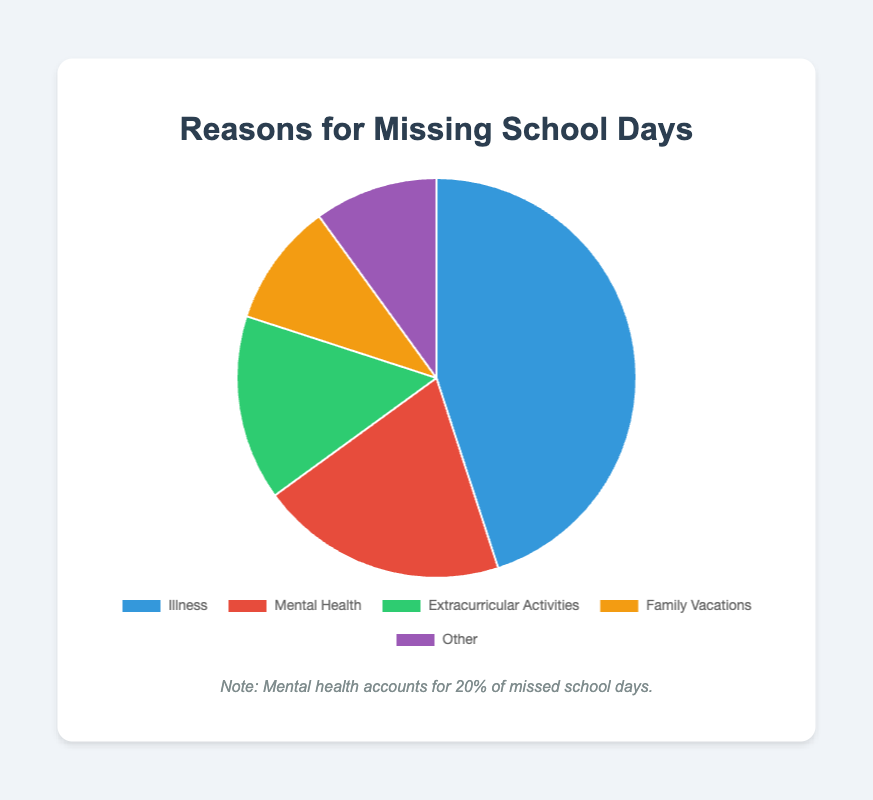What percentage of missed school days is due to illness? Illness is shown in the chart with a percentage value of 45%. Simply refer to the label for "Illness" to get the answer.
Answer: 45% What is the difference between the percentages of missed school days due to illness and mental health? The percentage for illness is 45%, and for mental health, it is 20%. Calculating the difference: 45% - 20% = 25%
Answer: 25% What percentage of missed school days is accounted for by extracurricular activities and family vacations combined? The percentages for extracurricular activities and family vacations are 15% and 10%, respectively. Adding them together: 15% + 10% = 25%
Answer: 25% Which category has the smallest percentage of missed school days and what is that percentage? Both "Family Vacations" and "Other" categories have the smallest percentage, each with 10%.
Answer: Family Vacations and Other: 10% Is the percentage of missed school days due to mental health greater than the percentage due to extracurricular activities? Mental health percentage is 20%, and extracurricular activities percentage is 15%. 20% is greater than 15%.
Answer: Yes Which category represents more than twice the percentage of missed school days compared to "Family Vacations"? "Family Vacations" is 10%. More than twice would be >20%. Illness (45%) is greater than 20%, but Mental Health (20%) is not greater than twice of 10%.
Answer: Illness What are the colors used to represent Mental Health and Extracurricular Activities in the pie chart? The color for Mental Health is red, and the color for Extracurricular Activities is green.
Answer: Red and Green What is the average percentage of missed school days across all categories? The percentages are 45%, 20%, 15%, 10%, and 10%. Sum = 45 + 20 + 15 + 10 + 10 = 100. Average = 100 / 5 = 20%
Answer: 20% How does the percentage of missed school days for mental health compare to the total percentage for all other reasons combined? Mental health is 20%. Other reasons combined: 45 (Illness) + 15 (Extracurricular Activities) + 10 (Family Vacations) + 10 (Other) = 80%.
Answer: Less In terms of percentage, what is the sum of missed school days for reasons other than illness? Percent for other reasons: 20% (Mental Health) + 15% (Extracurricular Activities) + 10% (Family Vacations) + 10% (Other) = 55%
Answer: 55% 